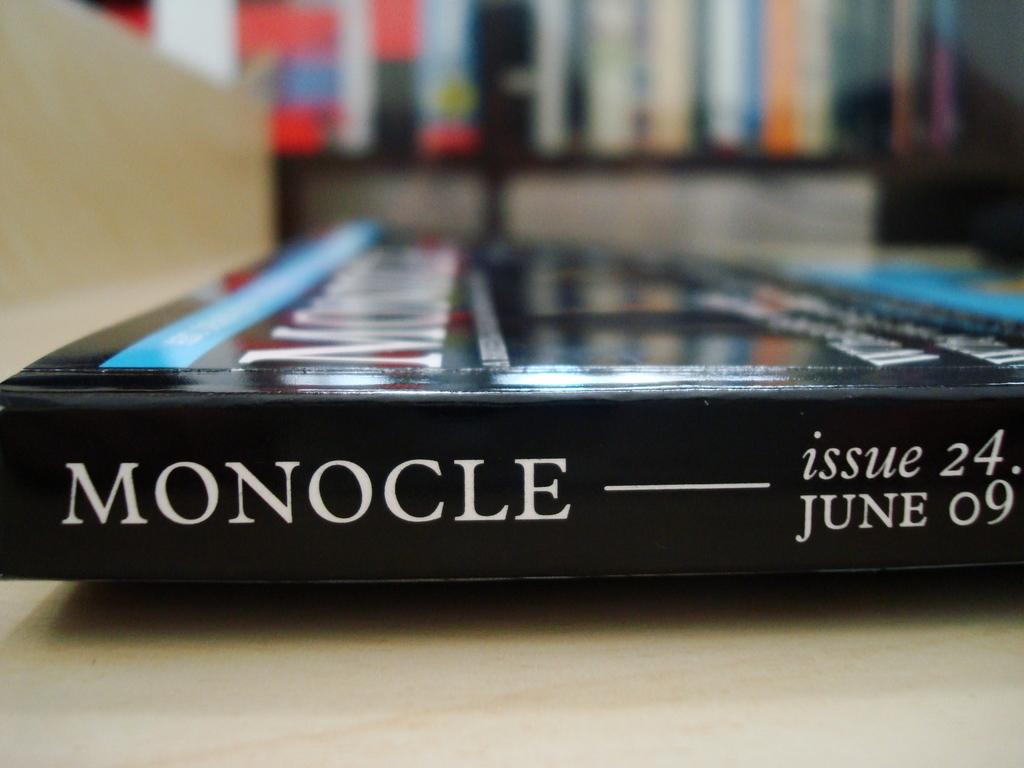<image>
Write a terse but informative summary of the picture. The library has available a magazine called Monocle. 